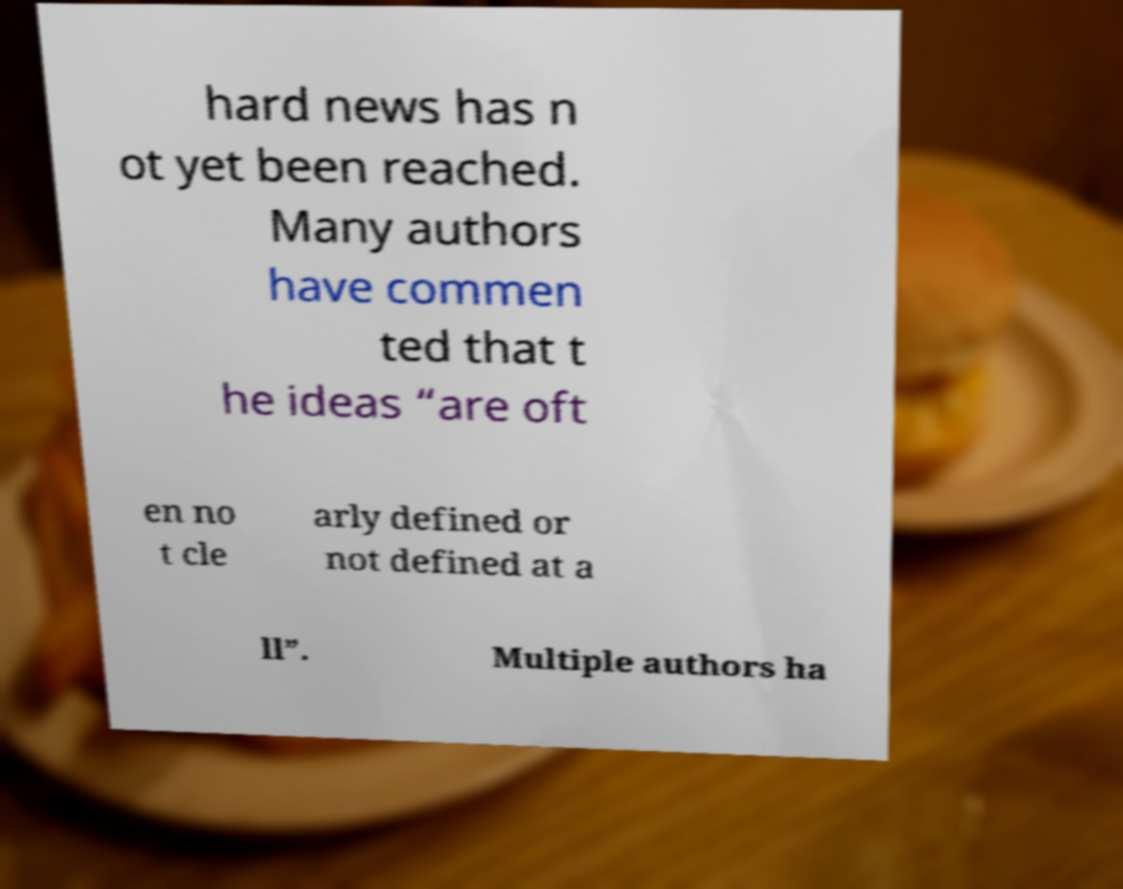Can you read and provide the text displayed in the image?This photo seems to have some interesting text. Can you extract and type it out for me? hard news has n ot yet been reached. Many authors have commen ted that t he ideas “are oft en no t cle arly defined or not defined at a ll”. Multiple authors ha 